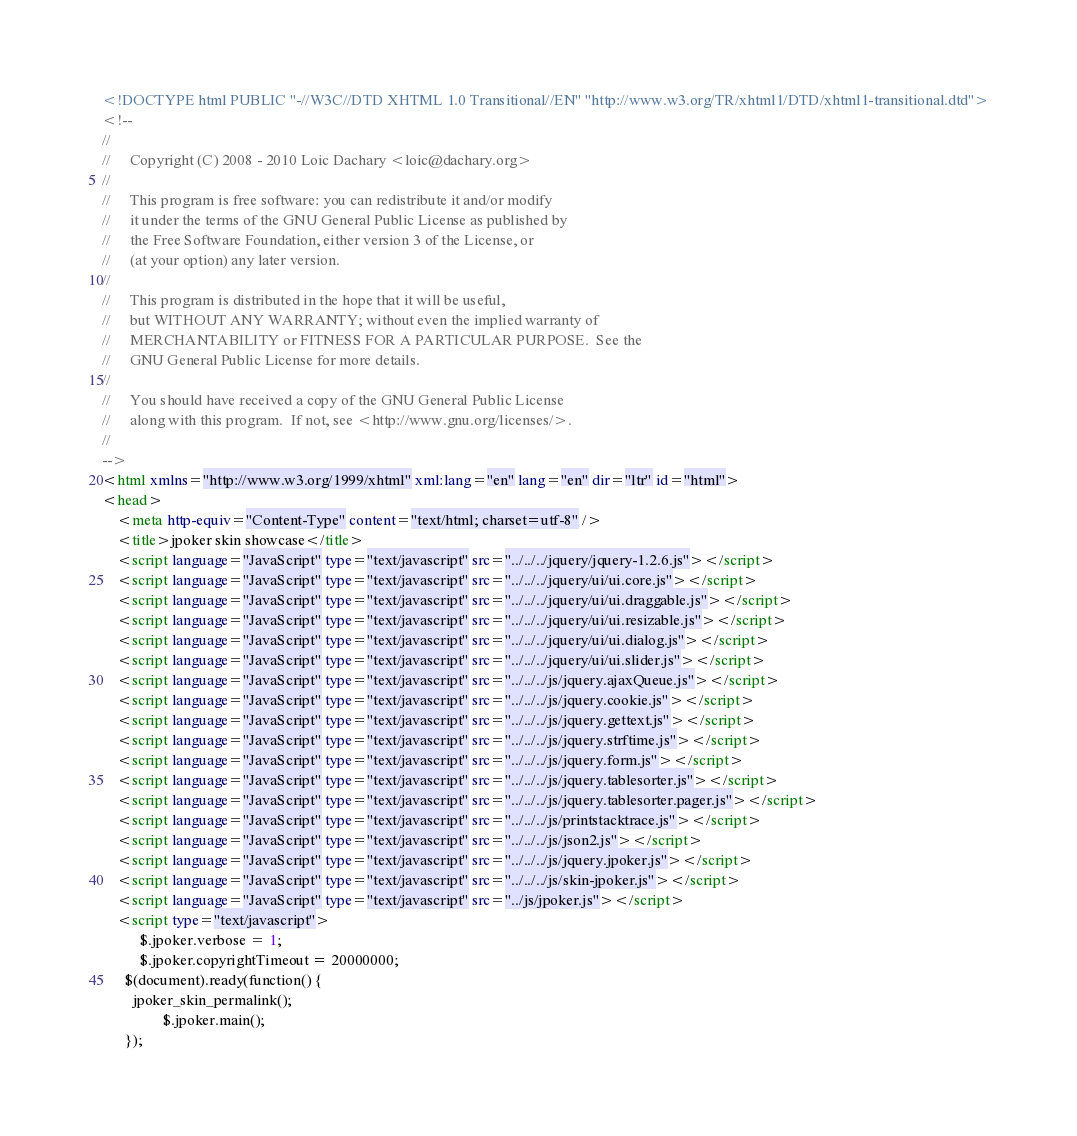Convert code to text. <code><loc_0><loc_0><loc_500><loc_500><_HTML_><!DOCTYPE html PUBLIC "-//W3C//DTD XHTML 1.0 Transitional//EN" "http://www.w3.org/TR/xhtml1/DTD/xhtml1-transitional.dtd">
<!--
//
//     Copyright (C) 2008 - 2010 Loic Dachary <loic@dachary.org>
//
//     This program is free software: you can redistribute it and/or modify
//     it under the terms of the GNU General Public License as published by
//     the Free Software Foundation, either version 3 of the License, or
//     (at your option) any later version.
//
//     This program is distributed in the hope that it will be useful,
//     but WITHOUT ANY WARRANTY; without even the implied warranty of
//     MERCHANTABILITY or FITNESS FOR A PARTICULAR PURPOSE.  See the
//     GNU General Public License for more details.
//
//     You should have received a copy of the GNU General Public License
//     along with this program.  If not, see <http://www.gnu.org/licenses/>.
//
-->
<html xmlns="http://www.w3.org/1999/xhtml" xml:lang="en" lang="en" dir="ltr" id="html">
<head>
	<meta http-equiv="Content-Type" content="text/html; charset=utf-8" />
	<title>jpoker skin showcase</title>
	<script language="JavaScript" type="text/javascript" src="../../../jquery/jquery-1.2.6.js"></script>
	<script language="JavaScript" type="text/javascript" src="../../../jquery/ui/ui.core.js"></script>
	<script language="JavaScript" type="text/javascript" src="../../../jquery/ui/ui.draggable.js"></script>
	<script language="JavaScript" type="text/javascript" src="../../../jquery/ui/ui.resizable.js"></script>
	<script language="JavaScript" type="text/javascript" src="../../../jquery/ui/ui.dialog.js"></script>
	<script language="JavaScript" type="text/javascript" src="../../../jquery/ui/ui.slider.js"></script>
	<script language="JavaScript" type="text/javascript" src="../../../js/jquery.ajaxQueue.js"></script>
	<script language="JavaScript" type="text/javascript" src="../../../js/jquery.cookie.js"></script>
	<script language="JavaScript" type="text/javascript" src="../../../js/jquery.gettext.js"></script>
	<script language="JavaScript" type="text/javascript" src="../../../js/jquery.strftime.js"></script>
	<script language="JavaScript" type="text/javascript" src="../../../js/jquery.form.js"></script>
	<script language="JavaScript" type="text/javascript" src="../../../js/jquery.tablesorter.js"></script>
	<script language="JavaScript" type="text/javascript" src="../../../js/jquery.tablesorter.pager.js"></script>
	<script language="JavaScript" type="text/javascript" src="../../../js/printstacktrace.js"></script>
	<script language="JavaScript" type="text/javascript" src="../../../js/json2.js"></script>
	<script language="JavaScript" type="text/javascript" src="../../../js/jquery.jpoker.js"></script>
	<script language="JavaScript" type="text/javascript" src="../../../js/skin-jpoker.js"></script>
	<script language="JavaScript" type="text/javascript" src="../js/jpoker.js"></script>
	<script type="text/javascript">
          $.jpoker.verbose = 1;
          $.jpoker.copyrightTimeout = 20000000;
	  $(document).ready(function() {
		jpoker_skin_permalink();
                $.jpoker.main();
	  });</code> 